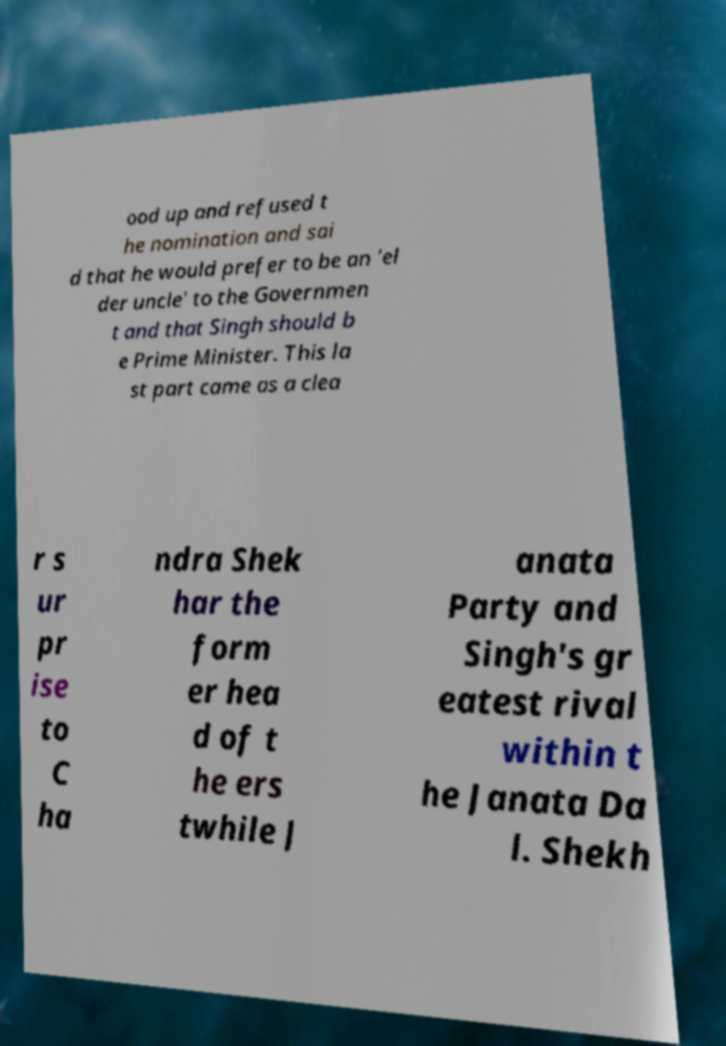Could you extract and type out the text from this image? ood up and refused t he nomination and sai d that he would prefer to be an 'el der uncle' to the Governmen t and that Singh should b e Prime Minister. This la st part came as a clea r s ur pr ise to C ha ndra Shek har the form er hea d of t he ers twhile J anata Party and Singh's gr eatest rival within t he Janata Da l. Shekh 